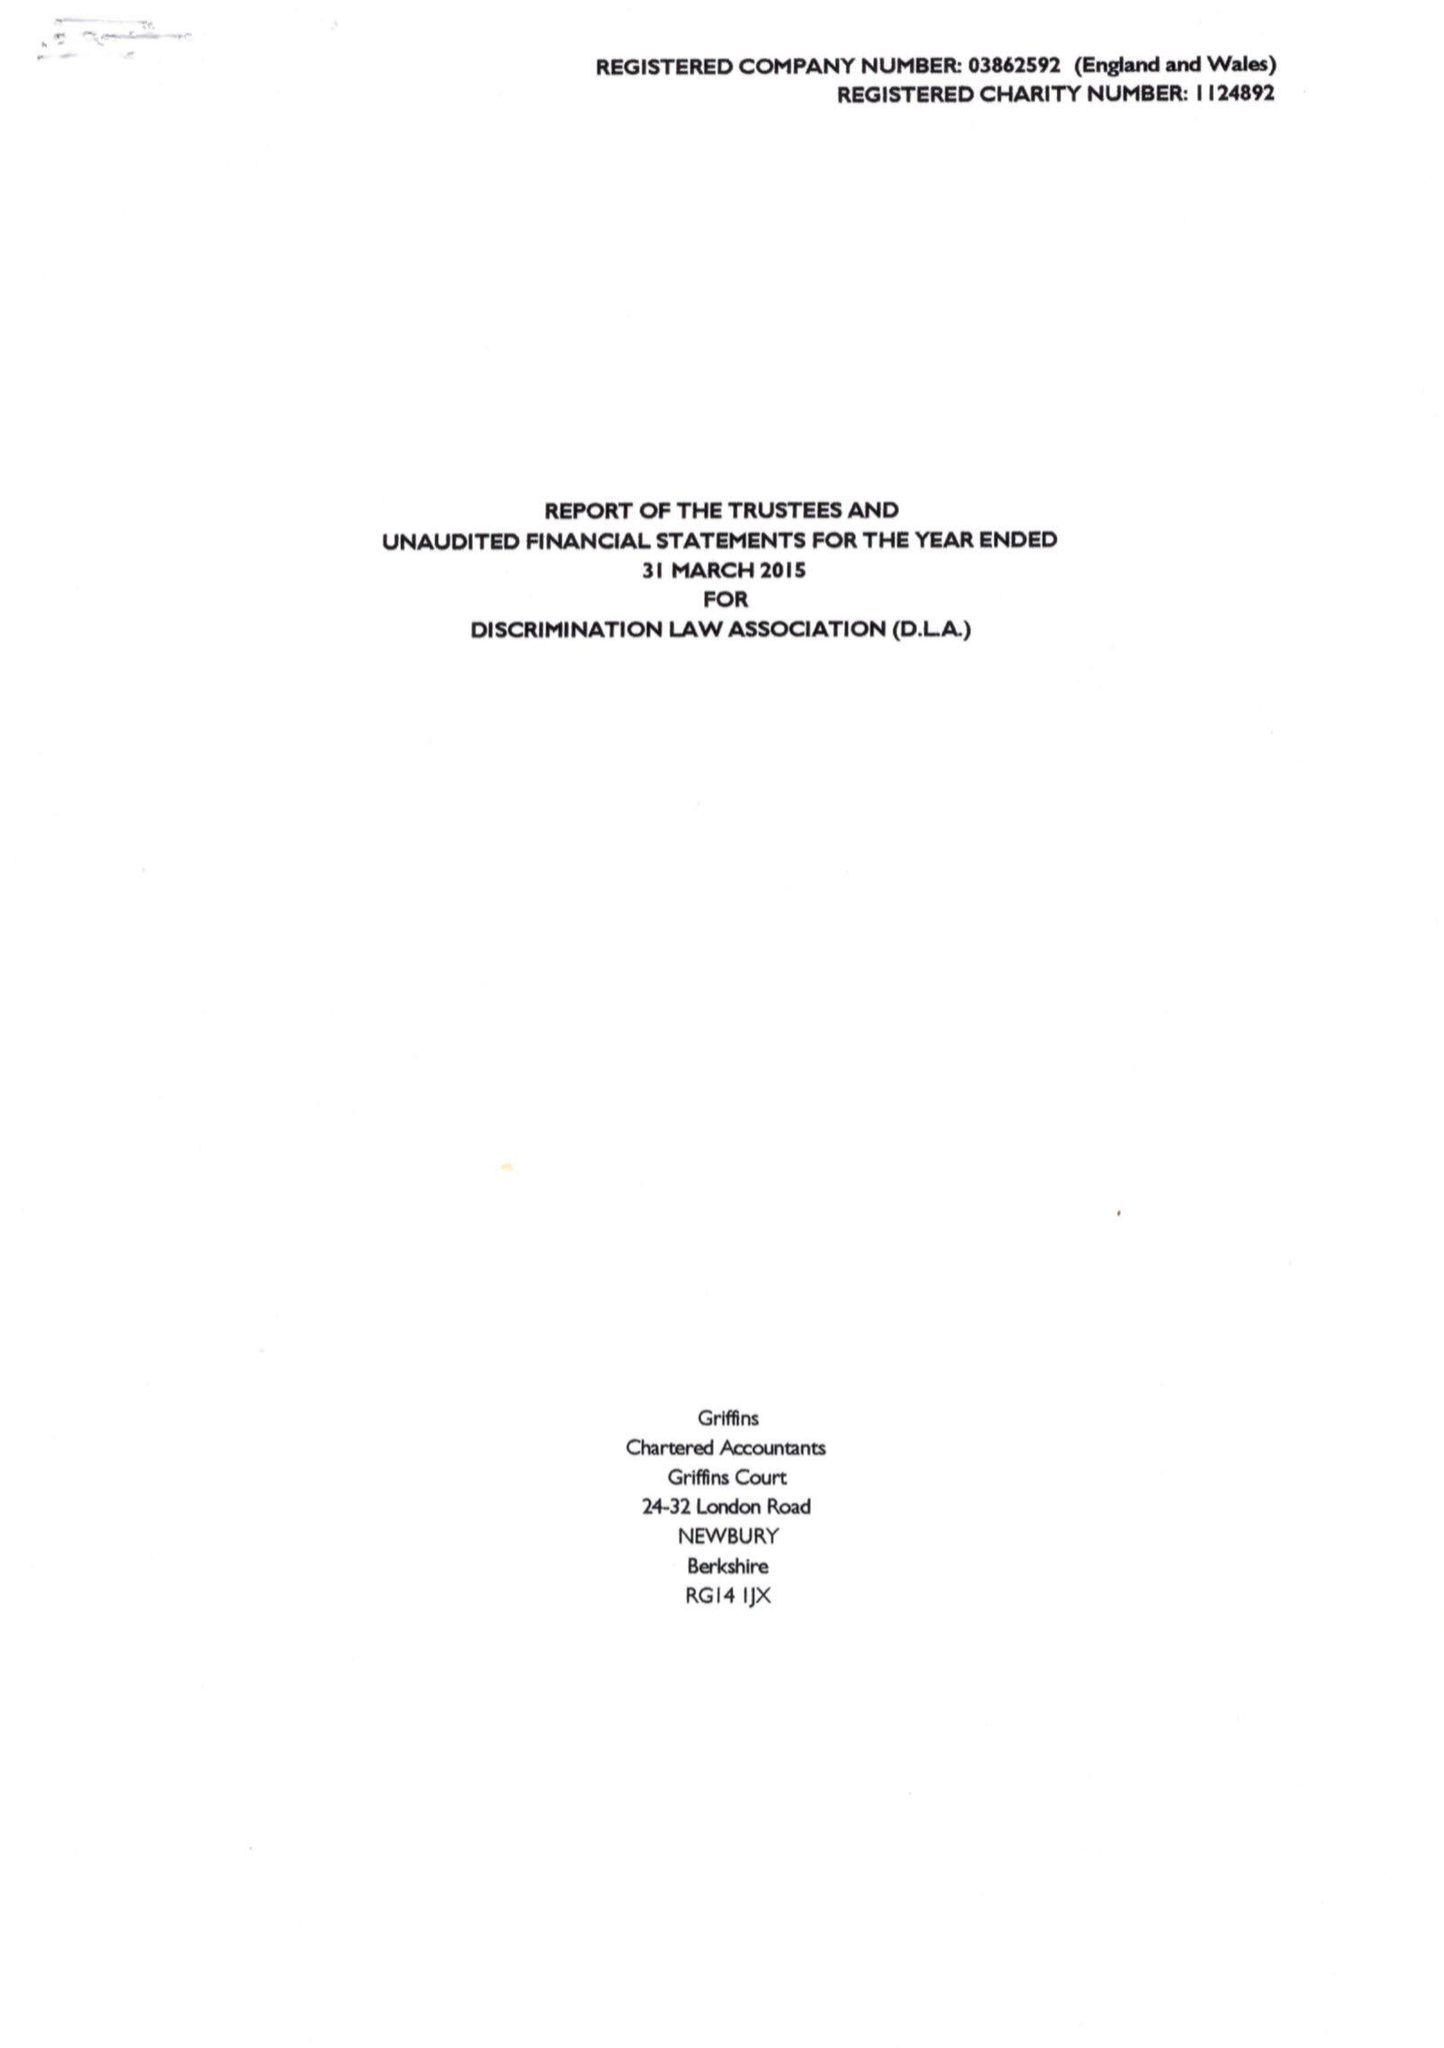What is the value for the address__post_town?
Answer the question using a single word or phrase. LONDON 